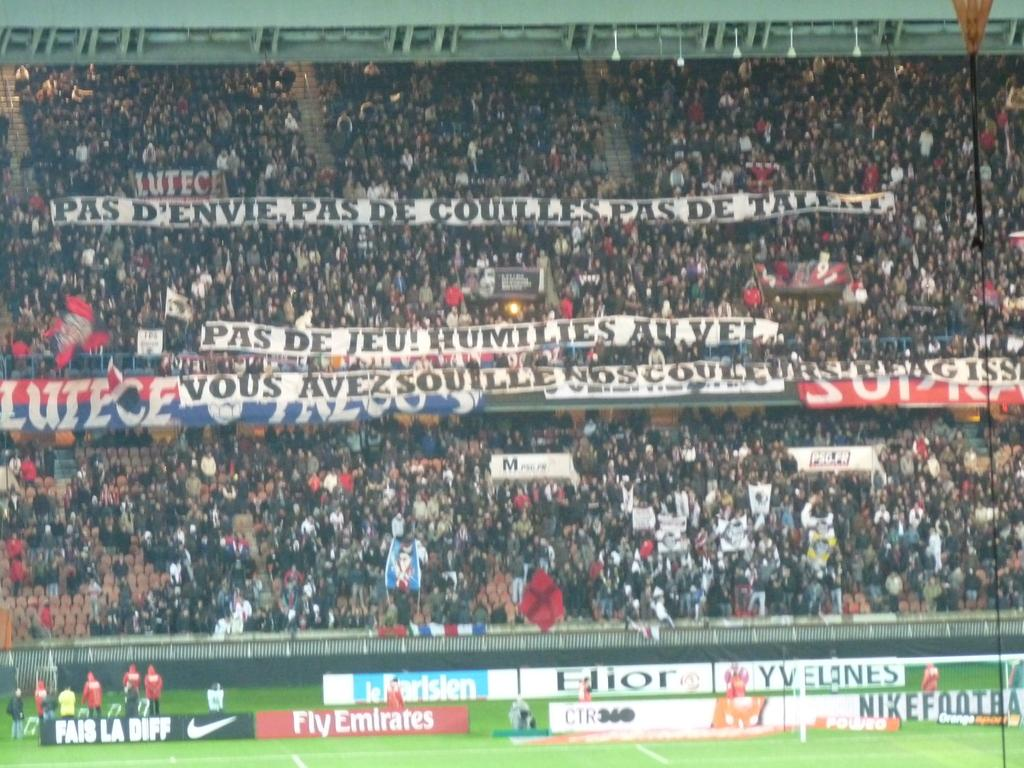<image>
Offer a succinct explanation of the picture presented. The crowd at a sporting event is holding up a big sign that reads Pas De Jeu Humilies Au Vel. 